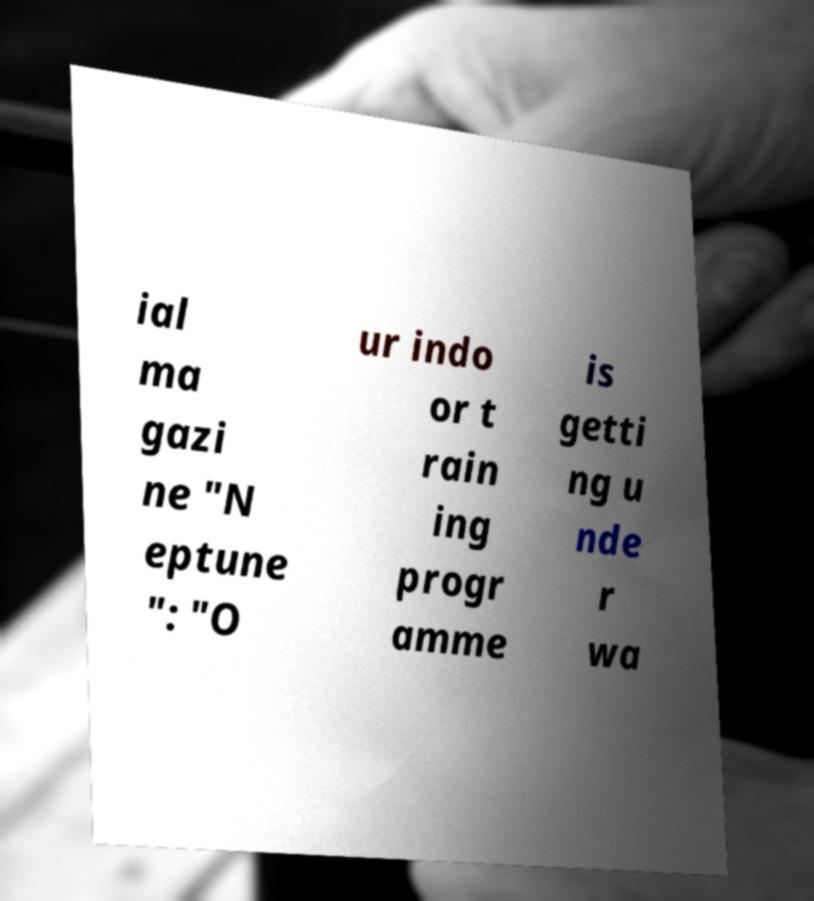There's text embedded in this image that I need extracted. Can you transcribe it verbatim? ial ma gazi ne "N eptune ": "O ur indo or t rain ing progr amme is getti ng u nde r wa 